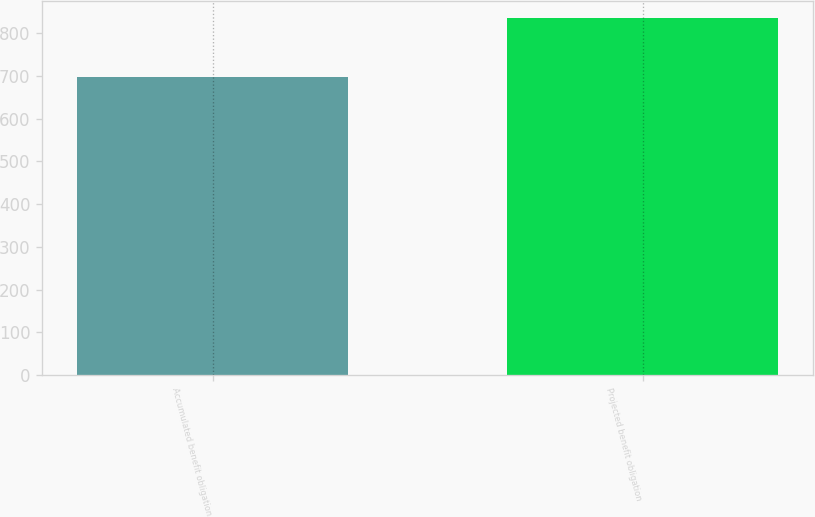<chart> <loc_0><loc_0><loc_500><loc_500><bar_chart><fcel>Accumulated benefit obligation<fcel>Projected benefit obligation<nl><fcel>697.4<fcel>835<nl></chart> 